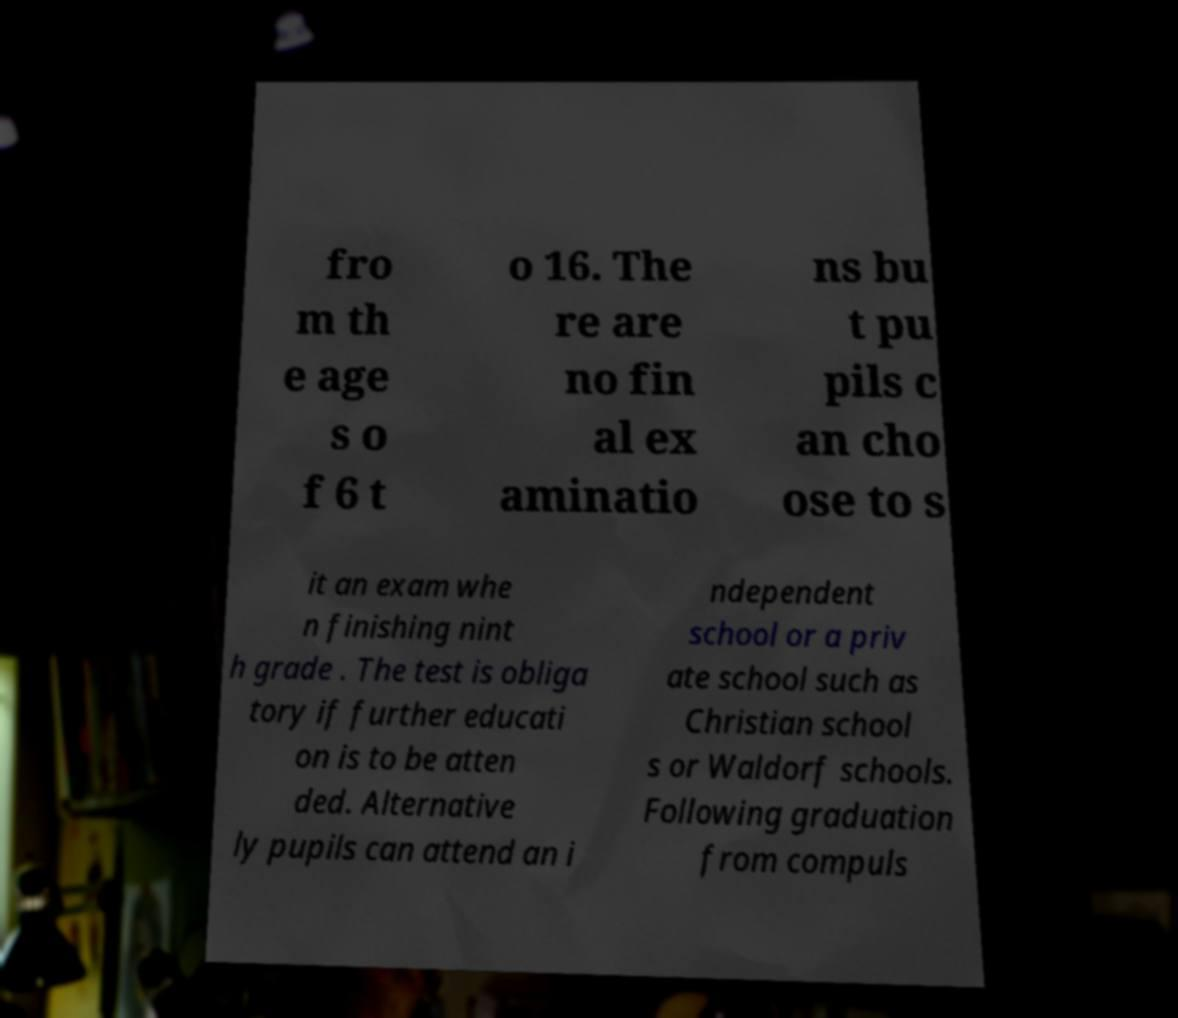Please identify and transcribe the text found in this image. fro m th e age s o f 6 t o 16. The re are no fin al ex aminatio ns bu t pu pils c an cho ose to s it an exam whe n finishing nint h grade . The test is obliga tory if further educati on is to be atten ded. Alternative ly pupils can attend an i ndependent school or a priv ate school such as Christian school s or Waldorf schools. Following graduation from compuls 